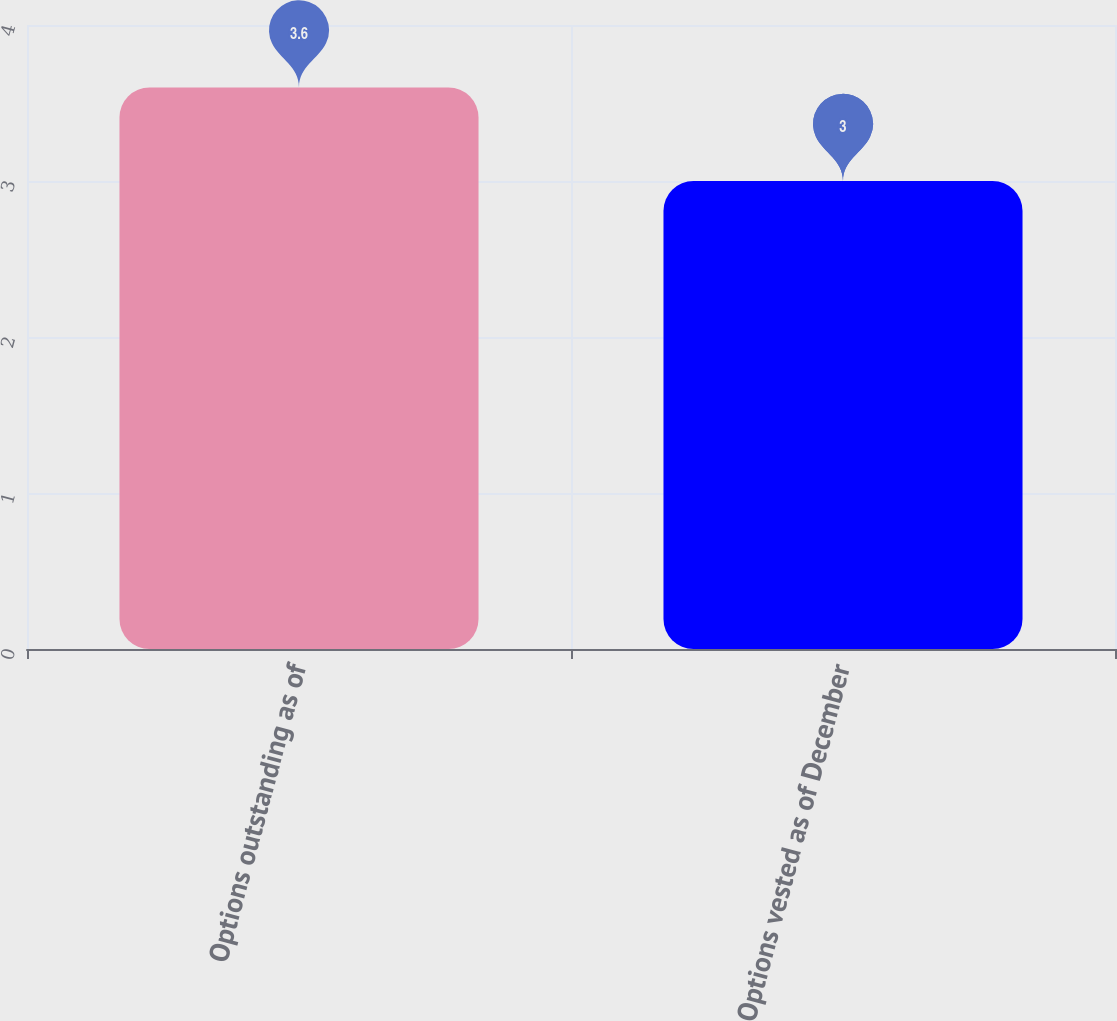<chart> <loc_0><loc_0><loc_500><loc_500><bar_chart><fcel>Options outstanding as of<fcel>Options vested as of December<nl><fcel>3.6<fcel>3<nl></chart> 